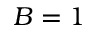<formula> <loc_0><loc_0><loc_500><loc_500>B = 1</formula> 